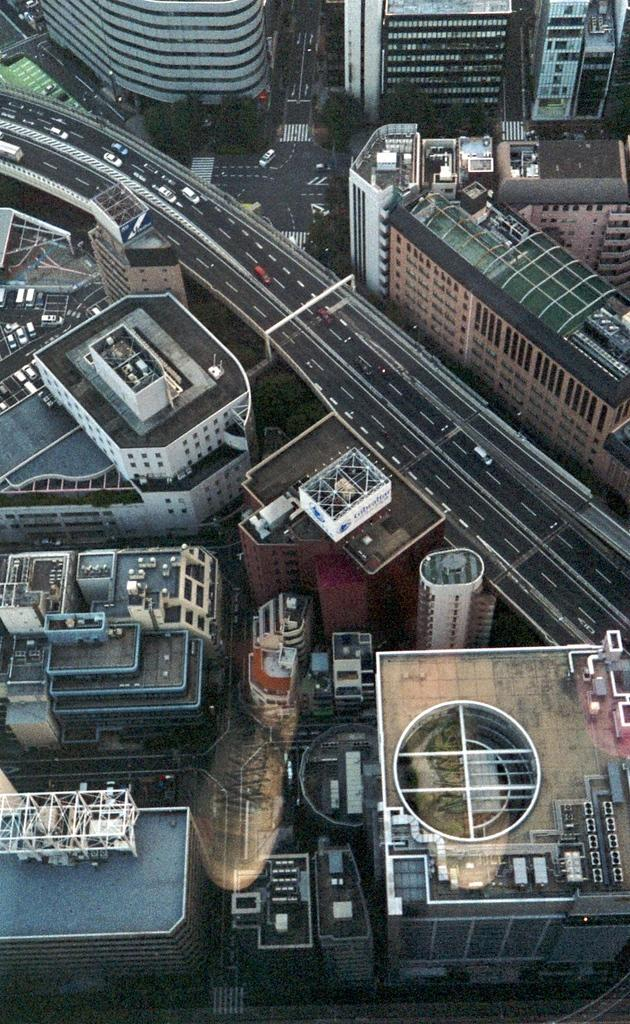What type of structures can be seen in the image? There are buildings in the image. What is happening on the road in the image? There are vehicles on the road in the image. Can you describe anything inside the buildings? There are objects visible inside the buildings. How many spiders are crawling on the buildings in the image? There are no spiders visible in the image; it only shows buildings, vehicles, and objects inside the buildings. 